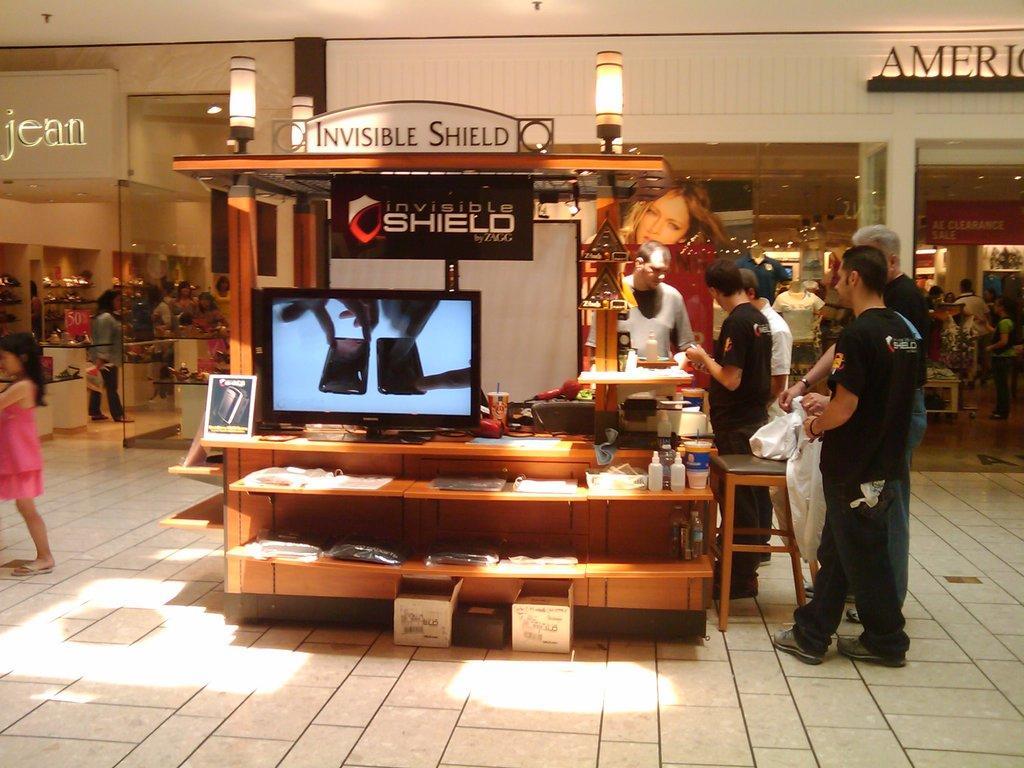Can you describe this image briefly? This image looks like a shopping mall. At the bottom, there is a floor. In the front, we can see a screen kept on the desk. And there are many things kept in the rack. On the left, we can see a girl wearing a pink dress. In the background, there are shops. And there are many people in this image. At the top, there are lights. 